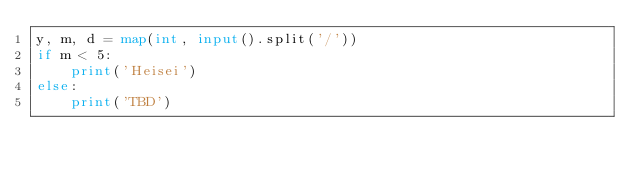<code> <loc_0><loc_0><loc_500><loc_500><_Python_>y, m, d = map(int, input().split('/'))
if m < 5:
    print('Heisei')
else:
    print('TBD')</code> 